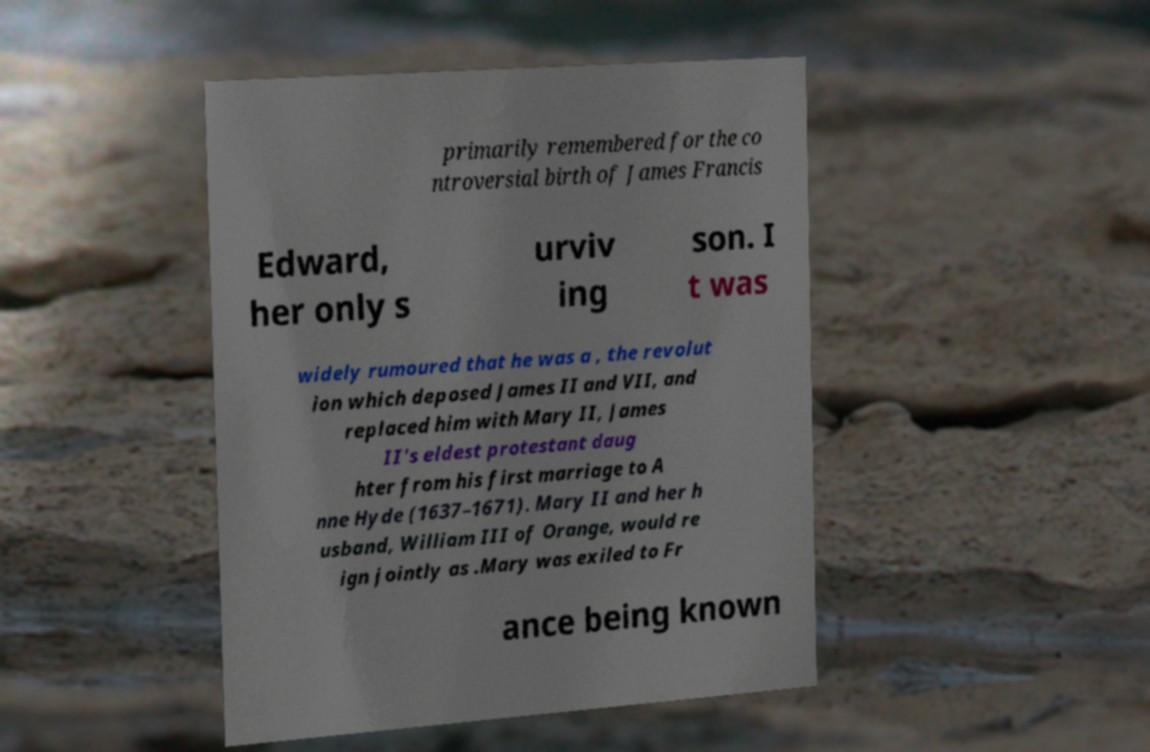Could you assist in decoding the text presented in this image and type it out clearly? primarily remembered for the co ntroversial birth of James Francis Edward, her only s urviv ing son. I t was widely rumoured that he was a , the revolut ion which deposed James II and VII, and replaced him with Mary II, James II's eldest protestant daug hter from his first marriage to A nne Hyde (1637–1671). Mary II and her h usband, William III of Orange, would re ign jointly as .Mary was exiled to Fr ance being known 